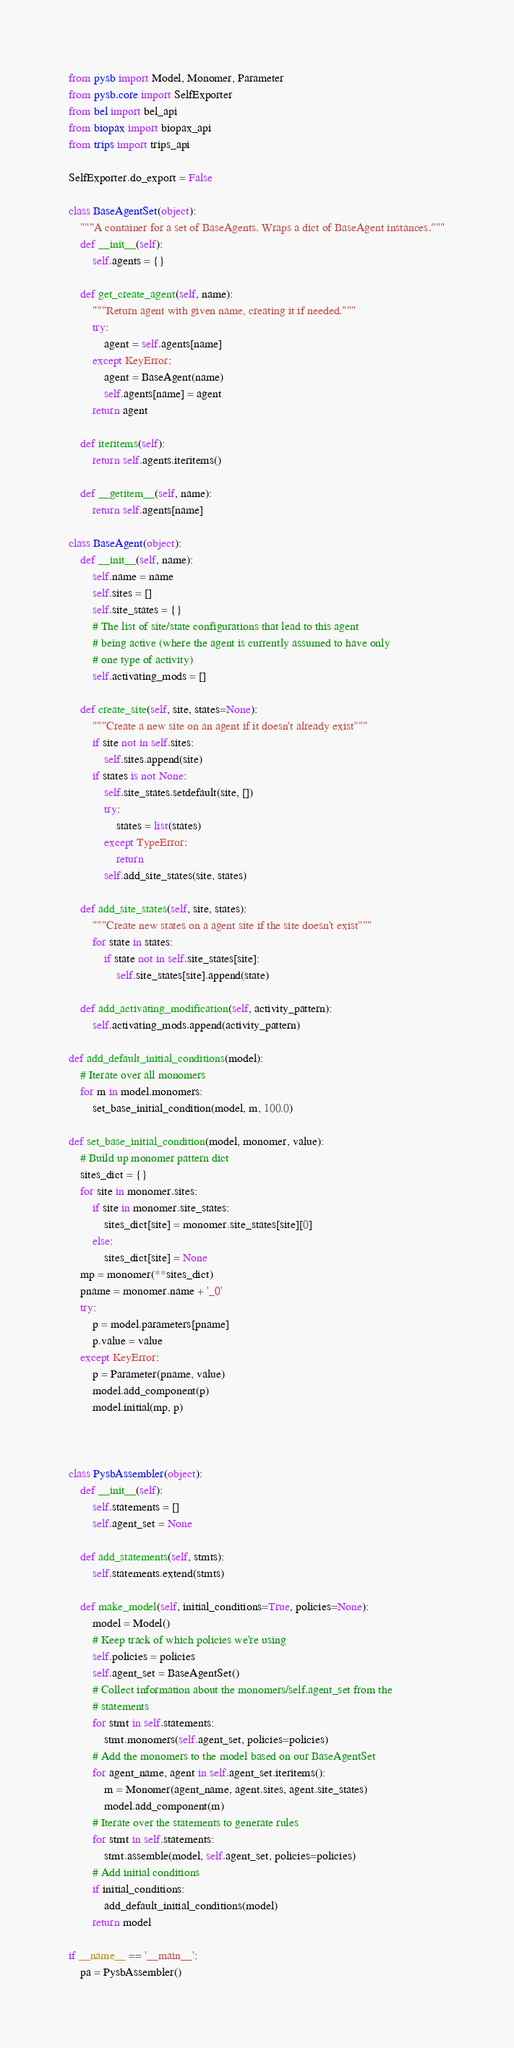Convert code to text. <code><loc_0><loc_0><loc_500><loc_500><_Python_>from pysb import Model, Monomer, Parameter
from pysb.core import SelfExporter
from bel import bel_api
from biopax import biopax_api
from trips import trips_api

SelfExporter.do_export = False

class BaseAgentSet(object):
    """A container for a set of BaseAgents. Wraps a dict of BaseAgent instances."""
    def __init__(self):
        self.agents = {}

    def get_create_agent(self, name):
        """Return agent with given name, creating it if needed."""
        try:
            agent = self.agents[name]
        except KeyError:
            agent = BaseAgent(name)
            self.agents[name] = agent
        return agent

    def iteritems(self):
        return self.agents.iteritems()

    def __getitem__(self, name):
        return self.agents[name]

class BaseAgent(object):
    def __init__(self, name):
        self.name = name
        self.sites = []
        self.site_states = {}
        # The list of site/state configurations that lead to this agent
        # being active (where the agent is currently assumed to have only
        # one type of activity)
        self.activating_mods = []

    def create_site(self, site, states=None):
        """Create a new site on an agent if it doesn't already exist"""
        if site not in self.sites:
            self.sites.append(site)
        if states is not None:
            self.site_states.setdefault(site, [])
            try:
                states = list(states)
            except TypeError:
                return
            self.add_site_states(site, states)

    def add_site_states(self, site, states):
        """Create new states on a agent site if the site doesn't exist"""
        for state in states:
            if state not in self.site_states[site]:
                self.site_states[site].append(state)

    def add_activating_modification(self, activity_pattern):
        self.activating_mods.append(activity_pattern)

def add_default_initial_conditions(model):
    # Iterate over all monomers
    for m in model.monomers:
        set_base_initial_condition(model, m, 100.0)

def set_base_initial_condition(model, monomer, value):
    # Build up monomer pattern dict
    sites_dict = {}
    for site in monomer.sites:
        if site in monomer.site_states:
            sites_dict[site] = monomer.site_states[site][0]
        else:
            sites_dict[site] = None
    mp = monomer(**sites_dict)
    pname = monomer.name + '_0'
    try:
        p = model.parameters[pname]
        p.value = value
    except KeyError:
        p = Parameter(pname, value)
        model.add_component(p)
        model.initial(mp, p)
    


class PysbAssembler(object):
    def __init__(self):
        self.statements = []
        self.agent_set = None

    def add_statements(self, stmts):
        self.statements.extend(stmts)

    def make_model(self, initial_conditions=True, policies=None):
        model = Model()
        # Keep track of which policies we're using
        self.policies = policies
        self.agent_set = BaseAgentSet()
        # Collect information about the monomers/self.agent_set from the
        # statements
        for stmt in self.statements:
            stmt.monomers(self.agent_set, policies=policies)
        # Add the monomers to the model based on our BaseAgentSet
        for agent_name, agent in self.agent_set.iteritems():
            m = Monomer(agent_name, agent.sites, agent.site_states)
            model.add_component(m)
        # Iterate over the statements to generate rules
        for stmt in self.statements:
            stmt.assemble(model, self.agent_set, policies=policies)
        # Add initial conditions
        if initial_conditions:
            add_default_initial_conditions(model)
        return model

if __name__ == '__main__':
    pa = PysbAssembler()</code> 